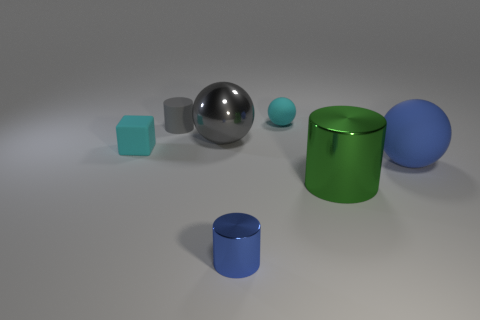Subtract all gray cubes. Subtract all blue balls. How many cubes are left? 1 Add 2 tiny gray matte blocks. How many objects exist? 9 Subtract all cylinders. How many objects are left? 4 Subtract 0 yellow cylinders. How many objects are left? 7 Subtract all small red shiny spheres. Subtract all blue metallic objects. How many objects are left? 6 Add 5 small cyan objects. How many small cyan objects are left? 7 Add 7 cyan rubber cubes. How many cyan rubber cubes exist? 8 